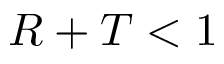<formula> <loc_0><loc_0><loc_500><loc_500>R + T < 1</formula> 